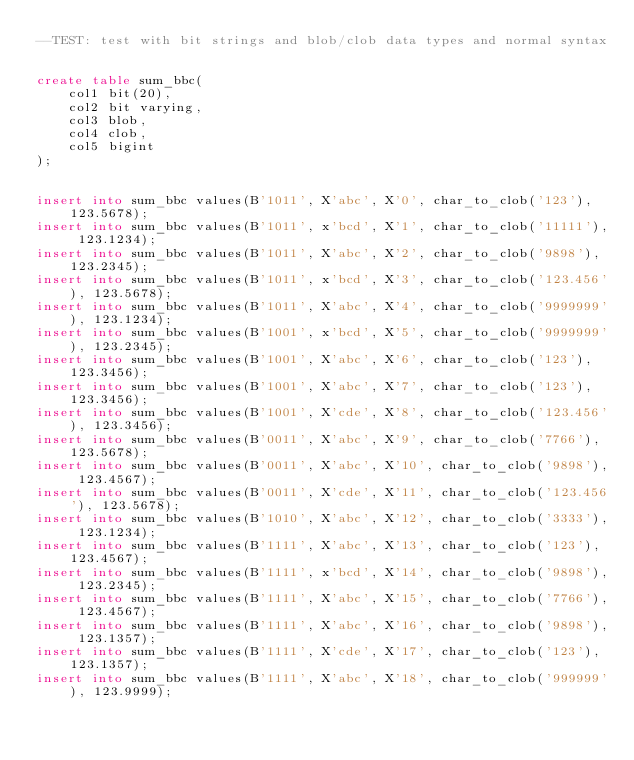Convert code to text. <code><loc_0><loc_0><loc_500><loc_500><_SQL_>--TEST: test with bit strings and blob/clob data types and normal syntax


create table sum_bbc(
	col1 bit(20),
	col2 bit varying, 
	col3 blob,
	col4 clob,
	col5 bigint
);


insert into sum_bbc values(B'1011', X'abc', X'0', char_to_clob('123'), 123.5678);
insert into sum_bbc values(B'1011', x'bcd', X'1', char_to_clob('11111'), 123.1234);
insert into sum_bbc values(B'1011', X'abc', X'2', char_to_clob('9898'), 123.2345);
insert into sum_bbc values(B'1011', x'bcd', X'3', char_to_clob('123.456'), 123.5678);
insert into sum_bbc values(B'1011', X'abc', X'4', char_to_clob('9999999'), 123.1234);
insert into sum_bbc values(B'1001', x'bcd', X'5', char_to_clob('9999999'), 123.2345);
insert into sum_bbc values(B'1001', X'abc', X'6', char_to_clob('123'), 123.3456);
insert into sum_bbc values(B'1001', X'abc', X'7', char_to_clob('123'), 123.3456);
insert into sum_bbc values(B'1001', X'cde', X'8', char_to_clob('123.456'), 123.3456);
insert into sum_bbc values(B'0011', X'abc', X'9', char_to_clob('7766'), 123.5678);
insert into sum_bbc values(B'0011', X'abc', X'10', char_to_clob('9898'), 123.4567);
insert into sum_bbc values(B'0011', X'cde', X'11', char_to_clob('123.456'), 123.5678);
insert into sum_bbc values(B'1010', X'abc', X'12', char_to_clob('3333'), 123.1234);
insert into sum_bbc values(B'1111', X'abc', X'13', char_to_clob('123'), 123.4567);
insert into sum_bbc values(B'1111', x'bcd', X'14', char_to_clob('9898'), 123.2345);
insert into sum_bbc values(B'1111', X'abc', X'15', char_to_clob('7766'), 123.4567);
insert into sum_bbc values(B'1111', X'abc', X'16', char_to_clob('9898'), 123.1357);
insert into sum_bbc values(B'1111', X'cde', X'17', char_to_clob('123'), 123.1357);
insert into sum_bbc values(B'1111', X'abc', X'18', char_to_clob('999999'), 123.9999);</code> 